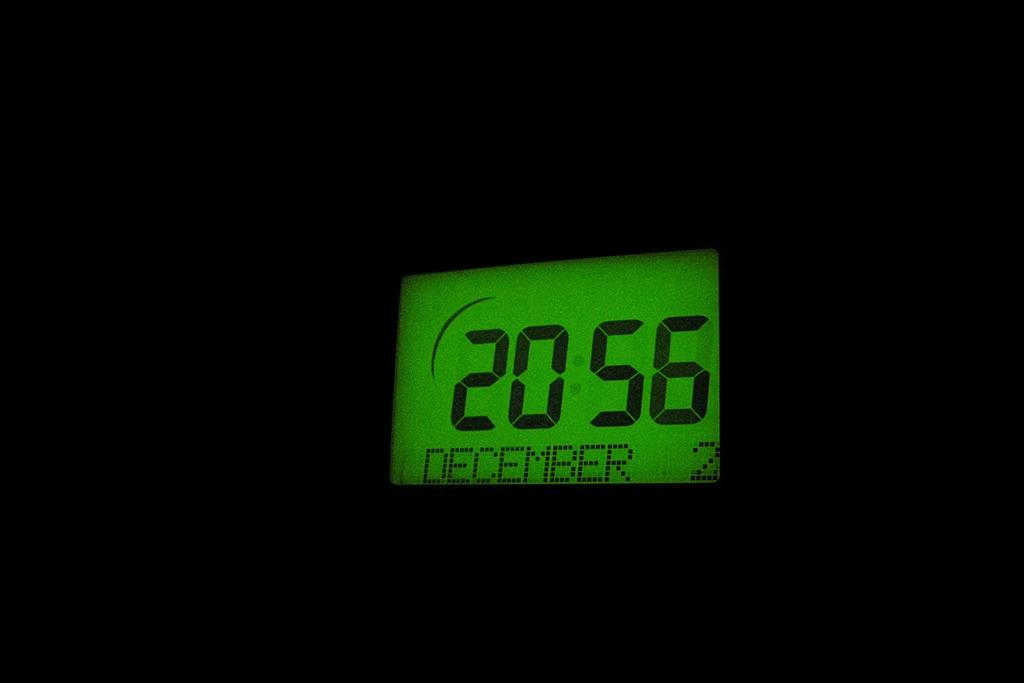<image>
Relay a brief, clear account of the picture shown. The readout of the digital screen reads out in military time for December 2nd. 